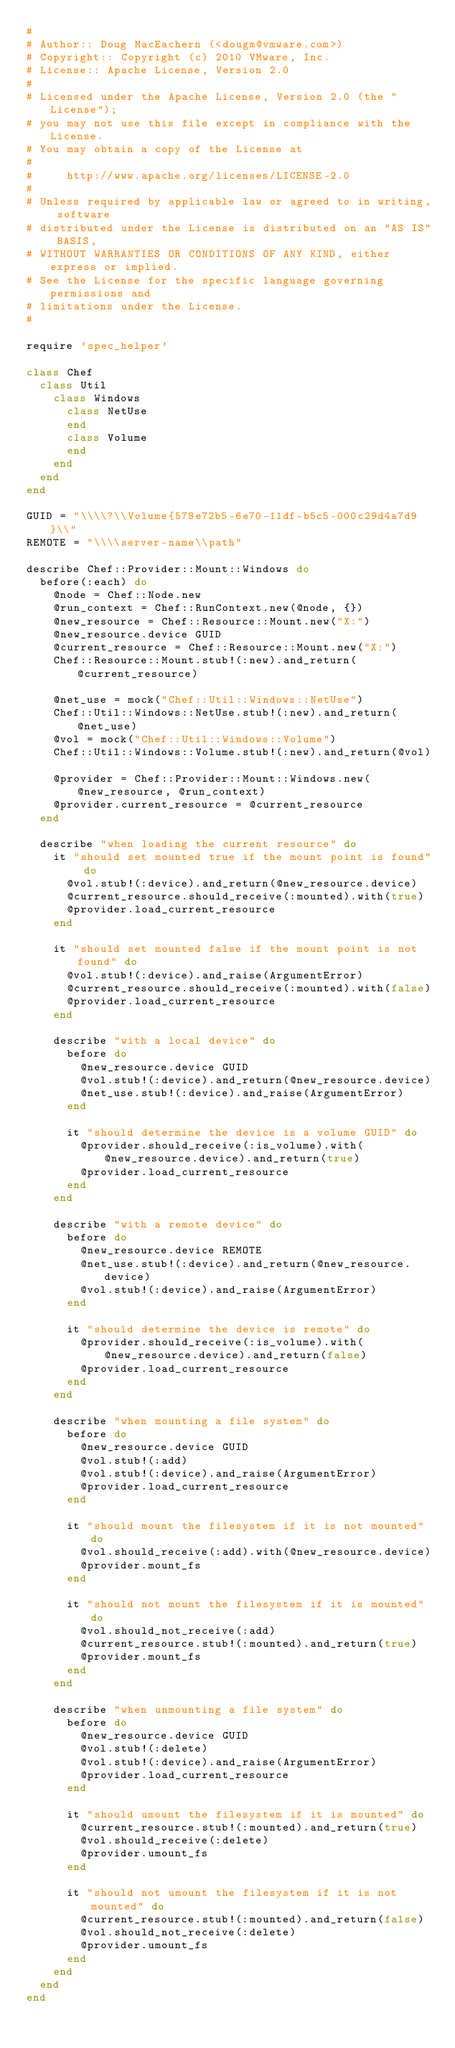<code> <loc_0><loc_0><loc_500><loc_500><_Ruby_>#
# Author:: Doug MacEachern (<dougm@vmware.com>)
# Copyright:: Copyright (c) 2010 VMware, Inc.
# License:: Apache License, Version 2.0
#
# Licensed under the Apache License, Version 2.0 (the "License");
# you may not use this file except in compliance with the License.
# You may obtain a copy of the License at
# 
#     http://www.apache.org/licenses/LICENSE-2.0
# 
# Unless required by applicable law or agreed to in writing, software
# distributed under the License is distributed on an "AS IS" BASIS,
# WITHOUT WARRANTIES OR CONDITIONS OF ANY KIND, either express or implied.
# See the License for the specific language governing permissions and
# limitations under the License.
#

require 'spec_helper'

class Chef
  class Util
    class Windows
      class NetUse
      end
      class Volume
      end
    end
  end
end

GUID = "\\\\?\\Volume{578e72b5-6e70-11df-b5c5-000c29d4a7d9}\\"
REMOTE = "\\\\server-name\\path"

describe Chef::Provider::Mount::Windows do
  before(:each) do
    @node = Chef::Node.new
    @run_context = Chef::RunContext.new(@node, {})
    @new_resource = Chef::Resource::Mount.new("X:")
    @new_resource.device GUID
    @current_resource = Chef::Resource::Mount.new("X:")
    Chef::Resource::Mount.stub!(:new).and_return(@current_resource)

    @net_use = mock("Chef::Util::Windows::NetUse")
    Chef::Util::Windows::NetUse.stub!(:new).and_return(@net_use)
    @vol = mock("Chef::Util::Windows::Volume")
    Chef::Util::Windows::Volume.stub!(:new).and_return(@vol)

    @provider = Chef::Provider::Mount::Windows.new(@new_resource, @run_context)
    @provider.current_resource = @current_resource
  end

  describe "when loading the current resource" do
    it "should set mounted true if the mount point is found" do
      @vol.stub!(:device).and_return(@new_resource.device)
      @current_resource.should_receive(:mounted).with(true)
      @provider.load_current_resource
    end

    it "should set mounted false if the mount point is not found" do
      @vol.stub!(:device).and_raise(ArgumentError)
      @current_resource.should_receive(:mounted).with(false)
      @provider.load_current_resource
    end

    describe "with a local device" do
      before do
        @new_resource.device GUID
        @vol.stub!(:device).and_return(@new_resource.device)
        @net_use.stub!(:device).and_raise(ArgumentError)
      end

      it "should determine the device is a volume GUID" do
        @provider.should_receive(:is_volume).with(@new_resource.device).and_return(true)
        @provider.load_current_resource
      end
    end

    describe "with a remote device" do
      before do
        @new_resource.device REMOTE
        @net_use.stub!(:device).and_return(@new_resource.device)
        @vol.stub!(:device).and_raise(ArgumentError)
      end

      it "should determine the device is remote" do
        @provider.should_receive(:is_volume).with(@new_resource.device).and_return(false)
        @provider.load_current_resource
      end
    end

    describe "when mounting a file system" do
      before do
        @new_resource.device GUID
        @vol.stub!(:add)
        @vol.stub!(:device).and_raise(ArgumentError)
        @provider.load_current_resource
      end

      it "should mount the filesystem if it is not mounted" do
        @vol.should_receive(:add).with(@new_resource.device)
        @provider.mount_fs
      end

      it "should not mount the filesystem if it is mounted" do
        @vol.should_not_receive(:add)
        @current_resource.stub!(:mounted).and_return(true)
        @provider.mount_fs
      end
    end

    describe "when unmounting a file system" do
      before do
        @new_resource.device GUID
        @vol.stub!(:delete)
        @vol.stub!(:device).and_raise(ArgumentError)
        @provider.load_current_resource
      end

      it "should umount the filesystem if it is mounted" do
        @current_resource.stub!(:mounted).and_return(true)
        @vol.should_receive(:delete)
        @provider.umount_fs
      end

      it "should not umount the filesystem if it is not mounted" do
        @current_resource.stub!(:mounted).and_return(false)
        @vol.should_not_receive(:delete)
        @provider.umount_fs
      end
    end
  end
end
</code> 